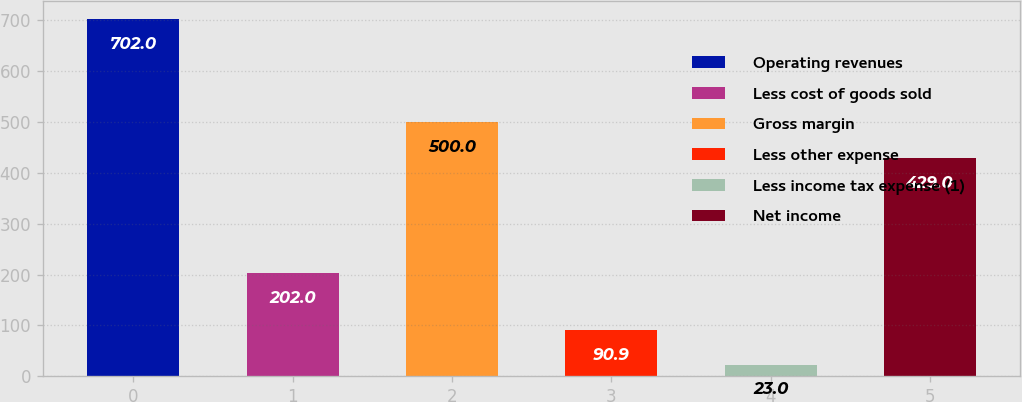Convert chart. <chart><loc_0><loc_0><loc_500><loc_500><bar_chart><fcel>Operating revenues<fcel>Less cost of goods sold<fcel>Gross margin<fcel>Less other expense<fcel>Less income tax expense (1)<fcel>Net income<nl><fcel>702<fcel>202<fcel>500<fcel>90.9<fcel>23<fcel>429<nl></chart> 